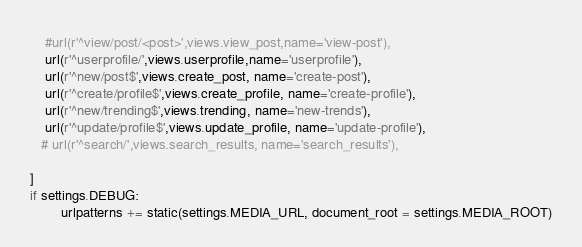Convert code to text. <code><loc_0><loc_0><loc_500><loc_500><_Python_>    #url(r'^view/post/<post>',views.view_post,name='view-post'),
    url(r'^userprofile/',views.userprofile,name='userprofile'),
    url(r'^new/post$',views.create_post, name='create-post'),
    url(r'^create/profile$',views.create_profile, name='create-profile'),
    url(r'^new/trending$',views.trending, name='new-trends'),
    url(r'^update/profile$',views.update_profile, name='update-profile'),
   # url(r'^search/',views.search_results, name='search_results'),

]
if settings.DEBUG:
        urlpatterns += static(settings.MEDIA_URL, document_root = settings.MEDIA_ROOT)</code> 